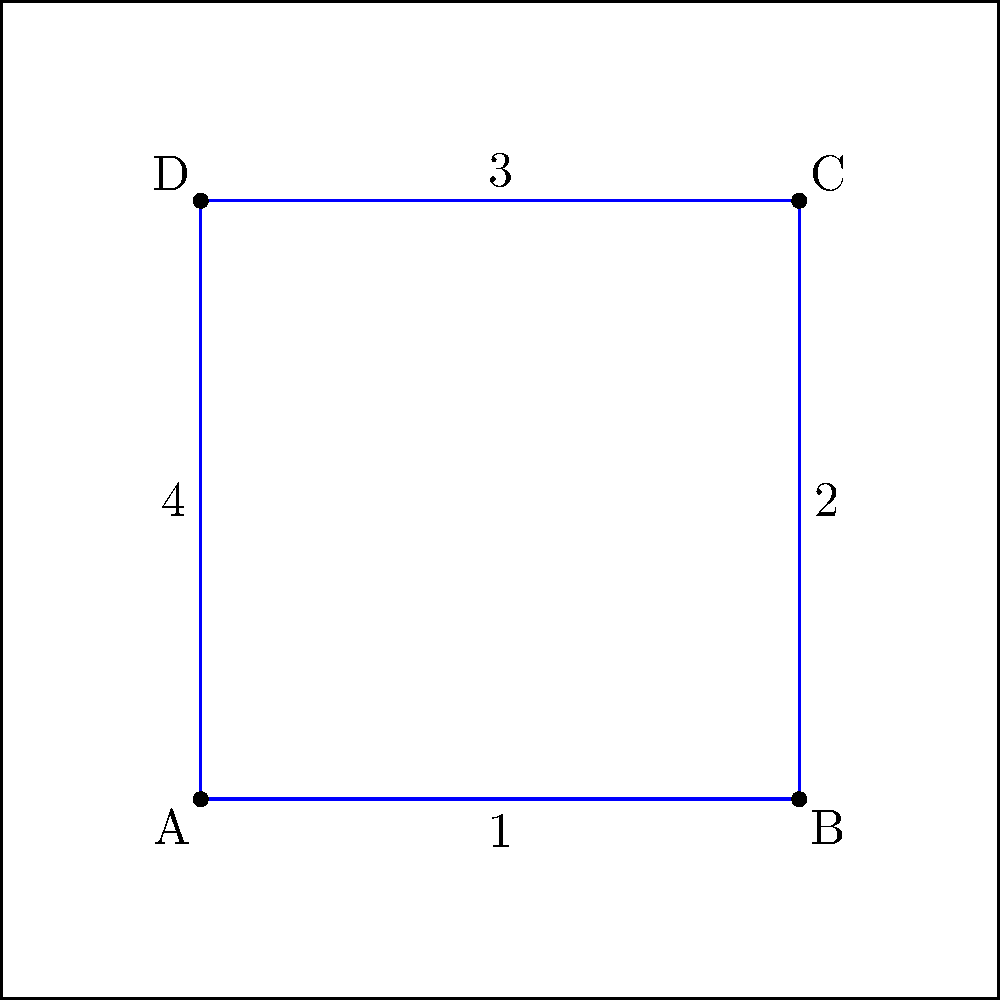A basketball player performs a complex dribbling pattern on the court, as shown in the diagram. The pattern forms a square ABCD with side length 3 units. If the pattern is subjected to a composite transformation consisting of a 90° clockwise rotation about point A followed by a translation of 2 units right and 1 unit up, what will be the coordinates of point C after the transformation? Let's approach this step-by-step:

1) First, we need to determine the initial coordinates of point C:
   A is at (1,1), and the square has a side length of 3 units.
   So, C is initially at (4,4).

2) Now, let's apply the 90° clockwise rotation about point A:
   - To rotate about A, we first translate A to the origin, rotate, then translate back.
   - Translating (-1,-1): C goes from (4,4) to (3,3)
   - 90° clockwise rotation: (x,y) → (y,-x)
     So (3,3) becomes (3,-3)
   - Translating back (+1,+1): (3,-3) becomes (4,-2)

3) After rotation, C is at (4,-2)

4) Now we apply the translation of 2 units right and 1 unit up:
   - 2 units right: x-coordinate changes from 4 to 6
   - 1 unit up: y-coordinate changes from -2 to -1

5) Therefore, after the composite transformation, point C ends up at (6,-1).
Answer: (6,-1) 